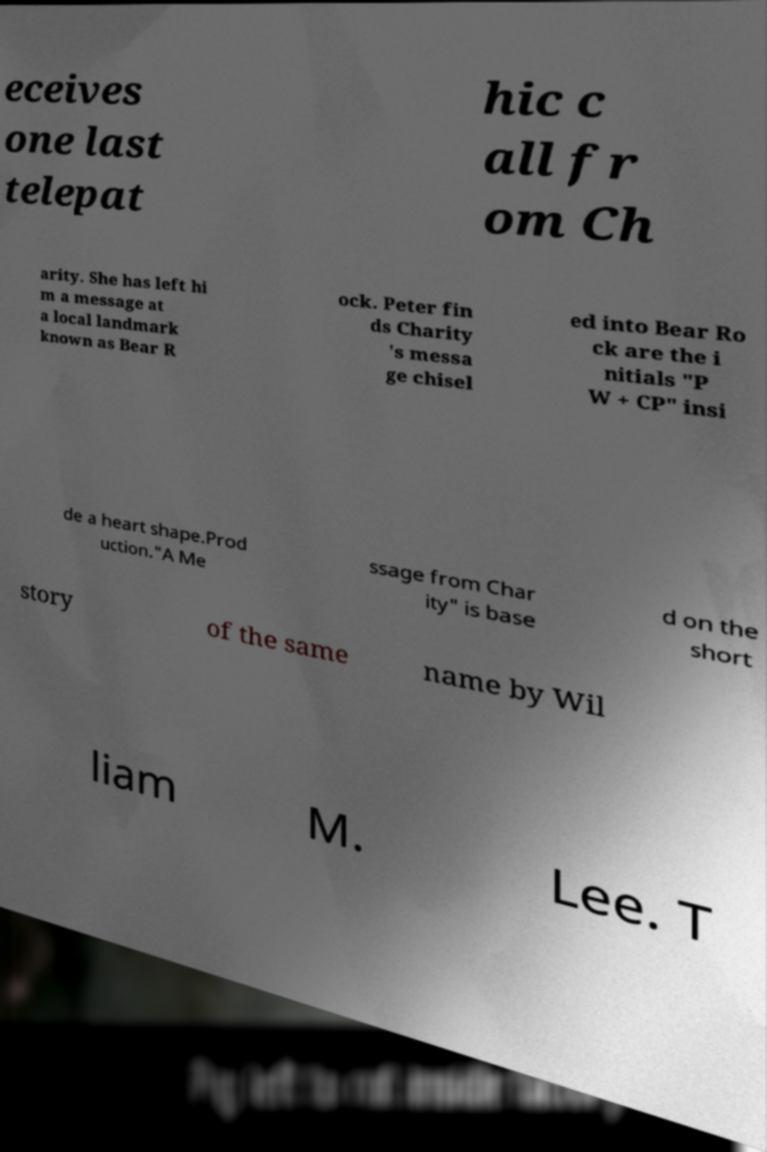Could you assist in decoding the text presented in this image and type it out clearly? eceives one last telepat hic c all fr om Ch arity. She has left hi m a message at a local landmark known as Bear R ock. Peter fin ds Charity 's messa ge chisel ed into Bear Ro ck are the i nitials "P W + CP" insi de a heart shape.Prod uction."A Me ssage from Char ity" is base d on the short story of the same name by Wil liam M. Lee. T 